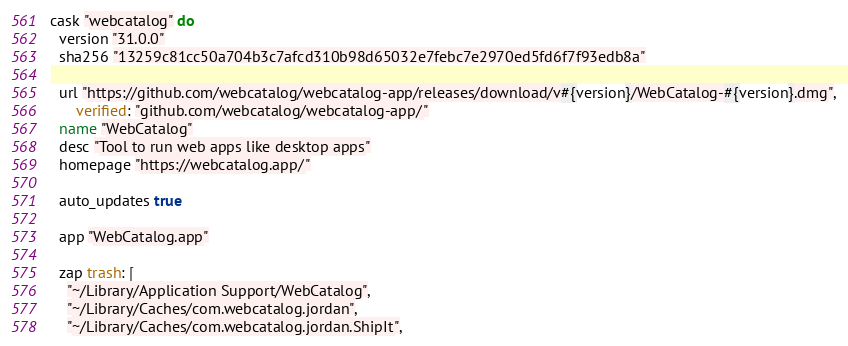<code> <loc_0><loc_0><loc_500><loc_500><_Ruby_>cask "webcatalog" do
  version "31.0.0"
  sha256 "13259c81cc50a704b3c7afcd310b98d65032e7febc7e2970ed5fd6f7f93edb8a"

  url "https://github.com/webcatalog/webcatalog-app/releases/download/v#{version}/WebCatalog-#{version}.dmg",
      verified: "github.com/webcatalog/webcatalog-app/"
  name "WebCatalog"
  desc "Tool to run web apps like desktop apps"
  homepage "https://webcatalog.app/"

  auto_updates true

  app "WebCatalog.app"

  zap trash: [
    "~/Library/Application Support/WebCatalog",
    "~/Library/Caches/com.webcatalog.jordan",
    "~/Library/Caches/com.webcatalog.jordan.ShipIt",</code> 